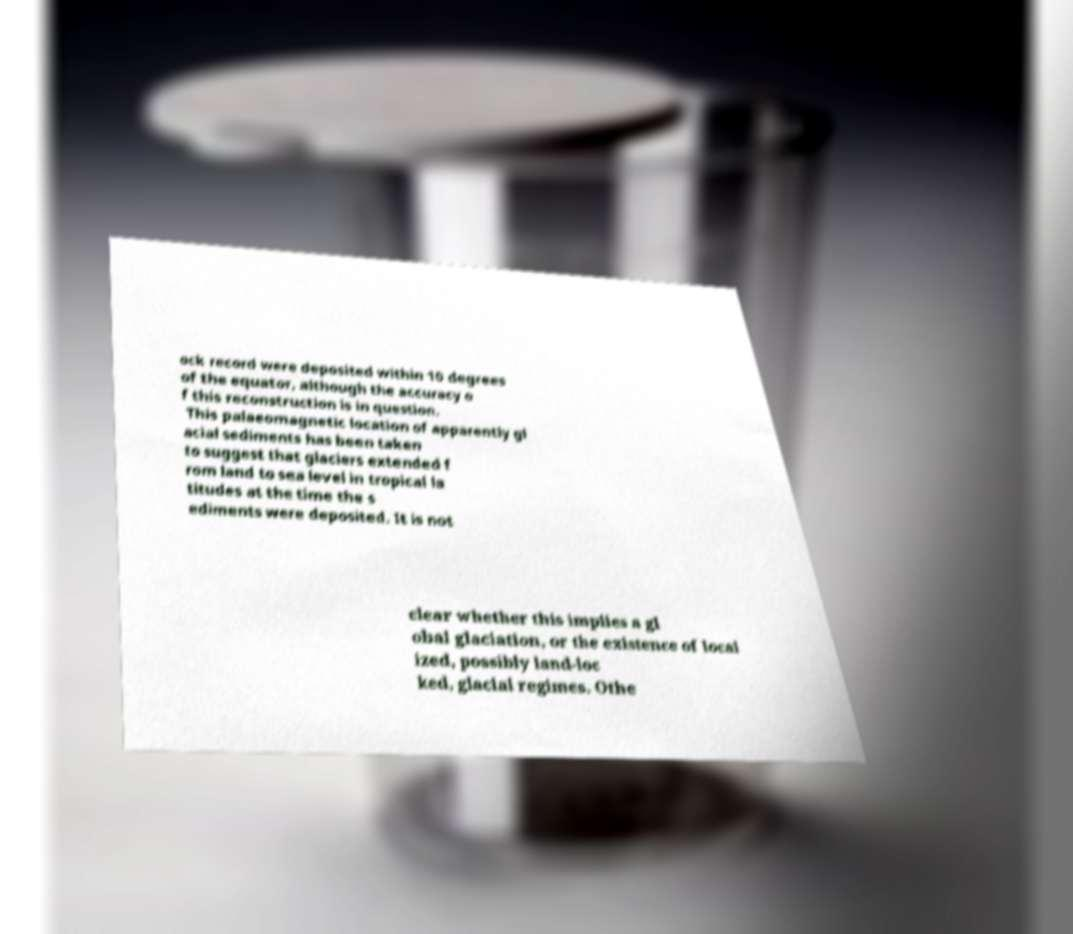Please identify and transcribe the text found in this image. ock record were deposited within 10 degrees of the equator, although the accuracy o f this reconstruction is in question. This palaeomagnetic location of apparently gl acial sediments has been taken to suggest that glaciers extended f rom land to sea level in tropical la titudes at the time the s ediments were deposited. It is not clear whether this implies a gl obal glaciation, or the existence of local ized, possibly land-loc ked, glacial regimes. Othe 